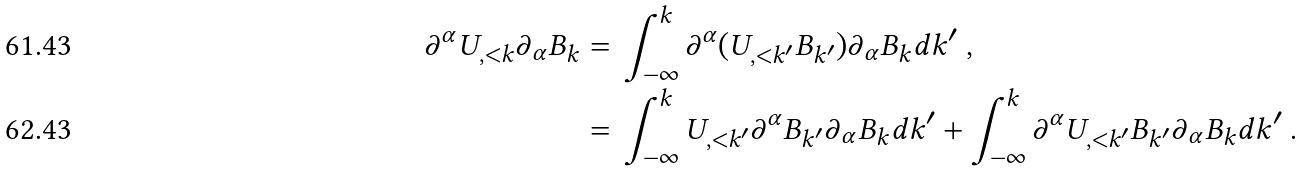<formula> <loc_0><loc_0><loc_500><loc_500>\partial ^ { \alpha } U _ { , < k } \partial _ { \alpha } B _ { k } = & \ \int _ { - \infty } ^ { k } \partial ^ { \alpha } ( U _ { , < k ^ { \prime } } B _ { k ^ { \prime } } ) \partial _ { \alpha } B _ { k } d k ^ { \prime } \ , \\ = & \ \int _ { - \infty } ^ { k } U _ { , < k ^ { \prime } } \partial ^ { \alpha } B _ { k ^ { \prime } } \partial _ { \alpha } B _ { k } d k ^ { \prime } + \int _ { - \infty } ^ { k } \partial ^ { \alpha } U _ { , < k ^ { \prime } } B _ { k ^ { \prime } } \partial _ { \alpha } B _ { k } d k ^ { \prime } \ .</formula> 